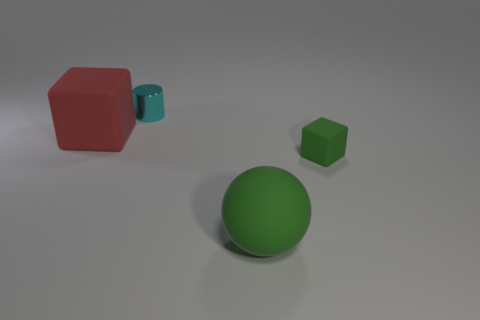How many other things are there of the same shape as the large green object?
Offer a very short reply. 0. There is a large matte object that is behind the tiny thing in front of the tiny object that is left of the large green object; what shape is it?
Keep it short and to the point. Cube. How many cylinders are either tiny green things or red matte things?
Ensure brevity in your answer.  0. There is a large matte object that is right of the cylinder; are there any large green matte spheres that are in front of it?
Give a very brief answer. No. Is there anything else that is made of the same material as the tiny block?
Your response must be concise. Yes. There is a small green matte thing; is its shape the same as the matte object in front of the small block?
Keep it short and to the point. No. What number of other objects are there of the same size as the cyan thing?
Ensure brevity in your answer.  1. What number of gray objects are tiny matte cubes or spheres?
Your answer should be very brief. 0. How many things are both to the right of the cyan shiny cylinder and behind the big matte ball?
Provide a short and direct response. 1. What material is the cube that is behind the cube right of the large thing to the left of the matte sphere?
Provide a short and direct response. Rubber. 